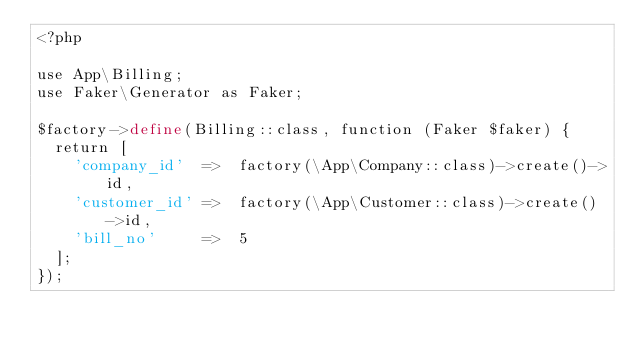Convert code to text. <code><loc_0><loc_0><loc_500><loc_500><_PHP_><?php

use App\Billing;
use Faker\Generator as Faker;

$factory->define(Billing::class, function (Faker $faker) {
  return [
    'company_id'  =>  factory(\App\Company::class)->create()->id,
    'customer_id' =>  factory(\App\Customer::class)->create()->id,
    'bill_no'     =>  5
  ];
});
</code> 